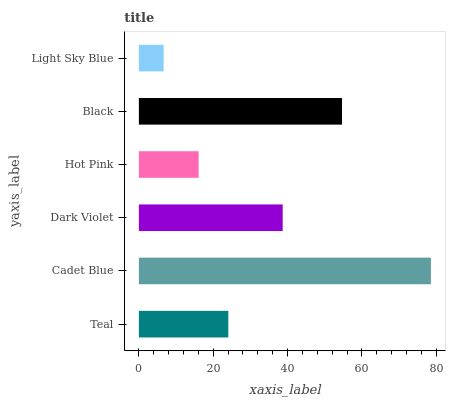Is Light Sky Blue the minimum?
Answer yes or no. Yes. Is Cadet Blue the maximum?
Answer yes or no. Yes. Is Dark Violet the minimum?
Answer yes or no. No. Is Dark Violet the maximum?
Answer yes or no. No. Is Cadet Blue greater than Dark Violet?
Answer yes or no. Yes. Is Dark Violet less than Cadet Blue?
Answer yes or no. Yes. Is Dark Violet greater than Cadet Blue?
Answer yes or no. No. Is Cadet Blue less than Dark Violet?
Answer yes or no. No. Is Dark Violet the high median?
Answer yes or no. Yes. Is Teal the low median?
Answer yes or no. Yes. Is Light Sky Blue the high median?
Answer yes or no. No. Is Dark Violet the low median?
Answer yes or no. No. 